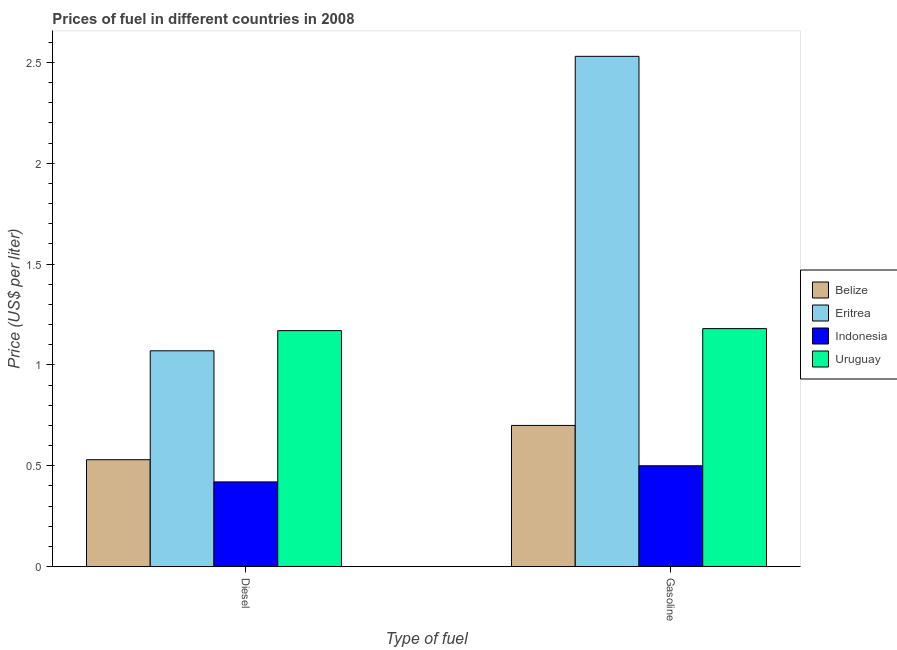How many groups of bars are there?
Provide a succinct answer. 2. Are the number of bars per tick equal to the number of legend labels?
Keep it short and to the point. Yes. Are the number of bars on each tick of the X-axis equal?
Offer a very short reply. Yes. How many bars are there on the 2nd tick from the right?
Provide a short and direct response. 4. What is the label of the 1st group of bars from the left?
Offer a very short reply. Diesel. What is the diesel price in Indonesia?
Your answer should be very brief. 0.42. Across all countries, what is the maximum gasoline price?
Offer a terse response. 2.53. Across all countries, what is the minimum diesel price?
Make the answer very short. 0.42. In which country was the gasoline price maximum?
Your response must be concise. Eritrea. What is the total diesel price in the graph?
Provide a short and direct response. 3.19. What is the difference between the gasoline price in Belize and that in Eritrea?
Your response must be concise. -1.83. What is the difference between the diesel price in Eritrea and the gasoline price in Belize?
Your response must be concise. 0.37. What is the average diesel price per country?
Your answer should be compact. 0.8. What is the difference between the gasoline price and diesel price in Indonesia?
Make the answer very short. 0.08. In how many countries, is the gasoline price greater than 0.6 US$ per litre?
Offer a terse response. 3. What is the ratio of the gasoline price in Eritrea to that in Belize?
Offer a terse response. 3.61. In how many countries, is the gasoline price greater than the average gasoline price taken over all countries?
Provide a succinct answer. 1. What does the 1st bar from the left in Diesel represents?
Ensure brevity in your answer.  Belize. What does the 1st bar from the right in Diesel represents?
Provide a short and direct response. Uruguay. Are all the bars in the graph horizontal?
Give a very brief answer. No. What is the difference between two consecutive major ticks on the Y-axis?
Give a very brief answer. 0.5. Are the values on the major ticks of Y-axis written in scientific E-notation?
Make the answer very short. No. Does the graph contain any zero values?
Keep it short and to the point. No. How many legend labels are there?
Your response must be concise. 4. How are the legend labels stacked?
Your response must be concise. Vertical. What is the title of the graph?
Ensure brevity in your answer.  Prices of fuel in different countries in 2008. What is the label or title of the X-axis?
Offer a very short reply. Type of fuel. What is the label or title of the Y-axis?
Your answer should be very brief. Price (US$ per liter). What is the Price (US$ per liter) of Belize in Diesel?
Make the answer very short. 0.53. What is the Price (US$ per liter) in Eritrea in Diesel?
Your answer should be compact. 1.07. What is the Price (US$ per liter) in Indonesia in Diesel?
Offer a terse response. 0.42. What is the Price (US$ per liter) in Uruguay in Diesel?
Offer a terse response. 1.17. What is the Price (US$ per liter) of Eritrea in Gasoline?
Provide a short and direct response. 2.53. What is the Price (US$ per liter) in Uruguay in Gasoline?
Make the answer very short. 1.18. Across all Type of fuel, what is the maximum Price (US$ per liter) of Belize?
Your response must be concise. 0.7. Across all Type of fuel, what is the maximum Price (US$ per liter) in Eritrea?
Ensure brevity in your answer.  2.53. Across all Type of fuel, what is the maximum Price (US$ per liter) of Uruguay?
Your answer should be very brief. 1.18. Across all Type of fuel, what is the minimum Price (US$ per liter) of Belize?
Give a very brief answer. 0.53. Across all Type of fuel, what is the minimum Price (US$ per liter) in Eritrea?
Your answer should be compact. 1.07. Across all Type of fuel, what is the minimum Price (US$ per liter) of Indonesia?
Your answer should be very brief. 0.42. Across all Type of fuel, what is the minimum Price (US$ per liter) in Uruguay?
Provide a succinct answer. 1.17. What is the total Price (US$ per liter) of Belize in the graph?
Provide a succinct answer. 1.23. What is the total Price (US$ per liter) of Eritrea in the graph?
Provide a succinct answer. 3.6. What is the total Price (US$ per liter) of Indonesia in the graph?
Your answer should be very brief. 0.92. What is the total Price (US$ per liter) of Uruguay in the graph?
Keep it short and to the point. 2.35. What is the difference between the Price (US$ per liter) in Belize in Diesel and that in Gasoline?
Your answer should be very brief. -0.17. What is the difference between the Price (US$ per liter) of Eritrea in Diesel and that in Gasoline?
Provide a succinct answer. -1.46. What is the difference between the Price (US$ per liter) in Indonesia in Diesel and that in Gasoline?
Offer a terse response. -0.08. What is the difference between the Price (US$ per liter) of Uruguay in Diesel and that in Gasoline?
Provide a short and direct response. -0.01. What is the difference between the Price (US$ per liter) in Belize in Diesel and the Price (US$ per liter) in Indonesia in Gasoline?
Provide a short and direct response. 0.03. What is the difference between the Price (US$ per liter) of Belize in Diesel and the Price (US$ per liter) of Uruguay in Gasoline?
Provide a succinct answer. -0.65. What is the difference between the Price (US$ per liter) of Eritrea in Diesel and the Price (US$ per liter) of Indonesia in Gasoline?
Offer a terse response. 0.57. What is the difference between the Price (US$ per liter) in Eritrea in Diesel and the Price (US$ per liter) in Uruguay in Gasoline?
Make the answer very short. -0.11. What is the difference between the Price (US$ per liter) in Indonesia in Diesel and the Price (US$ per liter) in Uruguay in Gasoline?
Give a very brief answer. -0.76. What is the average Price (US$ per liter) of Belize per Type of fuel?
Offer a very short reply. 0.61. What is the average Price (US$ per liter) of Indonesia per Type of fuel?
Offer a very short reply. 0.46. What is the average Price (US$ per liter) of Uruguay per Type of fuel?
Offer a terse response. 1.18. What is the difference between the Price (US$ per liter) of Belize and Price (US$ per liter) of Eritrea in Diesel?
Offer a very short reply. -0.54. What is the difference between the Price (US$ per liter) of Belize and Price (US$ per liter) of Indonesia in Diesel?
Your answer should be very brief. 0.11. What is the difference between the Price (US$ per liter) in Belize and Price (US$ per liter) in Uruguay in Diesel?
Make the answer very short. -0.64. What is the difference between the Price (US$ per liter) in Eritrea and Price (US$ per liter) in Indonesia in Diesel?
Keep it short and to the point. 0.65. What is the difference between the Price (US$ per liter) of Indonesia and Price (US$ per liter) of Uruguay in Diesel?
Ensure brevity in your answer.  -0.75. What is the difference between the Price (US$ per liter) in Belize and Price (US$ per liter) in Eritrea in Gasoline?
Provide a short and direct response. -1.83. What is the difference between the Price (US$ per liter) in Belize and Price (US$ per liter) in Indonesia in Gasoline?
Keep it short and to the point. 0.2. What is the difference between the Price (US$ per liter) of Belize and Price (US$ per liter) of Uruguay in Gasoline?
Give a very brief answer. -0.48. What is the difference between the Price (US$ per liter) of Eritrea and Price (US$ per liter) of Indonesia in Gasoline?
Provide a succinct answer. 2.03. What is the difference between the Price (US$ per liter) in Eritrea and Price (US$ per liter) in Uruguay in Gasoline?
Provide a succinct answer. 1.35. What is the difference between the Price (US$ per liter) of Indonesia and Price (US$ per liter) of Uruguay in Gasoline?
Offer a very short reply. -0.68. What is the ratio of the Price (US$ per liter) of Belize in Diesel to that in Gasoline?
Your answer should be compact. 0.76. What is the ratio of the Price (US$ per liter) of Eritrea in Diesel to that in Gasoline?
Make the answer very short. 0.42. What is the ratio of the Price (US$ per liter) of Indonesia in Diesel to that in Gasoline?
Your answer should be compact. 0.84. What is the difference between the highest and the second highest Price (US$ per liter) in Belize?
Offer a very short reply. 0.17. What is the difference between the highest and the second highest Price (US$ per liter) of Eritrea?
Your answer should be compact. 1.46. What is the difference between the highest and the second highest Price (US$ per liter) of Uruguay?
Make the answer very short. 0.01. What is the difference between the highest and the lowest Price (US$ per liter) in Belize?
Give a very brief answer. 0.17. What is the difference between the highest and the lowest Price (US$ per liter) of Eritrea?
Offer a terse response. 1.46. What is the difference between the highest and the lowest Price (US$ per liter) in Indonesia?
Provide a succinct answer. 0.08. What is the difference between the highest and the lowest Price (US$ per liter) of Uruguay?
Provide a short and direct response. 0.01. 